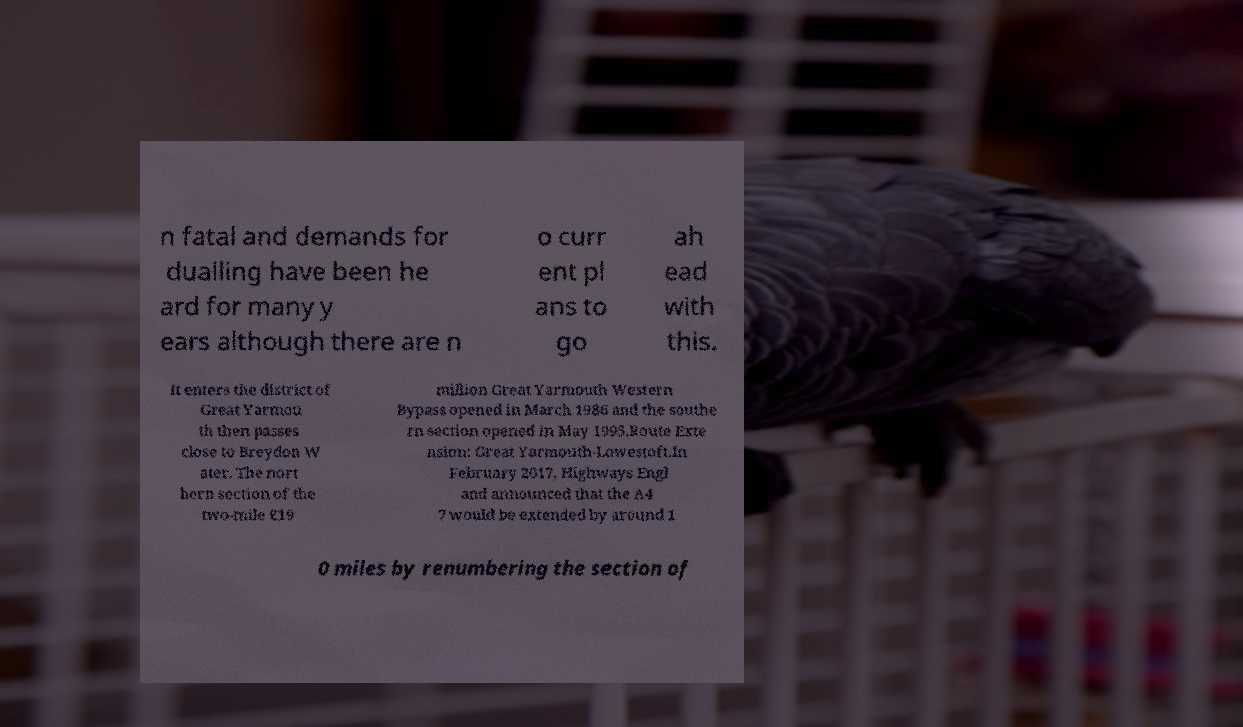For documentation purposes, I need the text within this image transcribed. Could you provide that? n fatal and demands for dualling have been he ard for many y ears although there are n o curr ent pl ans to go ah ead with this. It enters the district of Great Yarmou th then passes close to Breydon W ater. The nort hern section of the two-mile £19 million Great Yarmouth Western Bypass opened in March 1986 and the southe rn section opened in May 1995.Route Exte nsion: Great Yarmouth-Lowestoft.In February 2017, Highways Engl and announced that the A4 7 would be extended by around 1 0 miles by renumbering the section of 